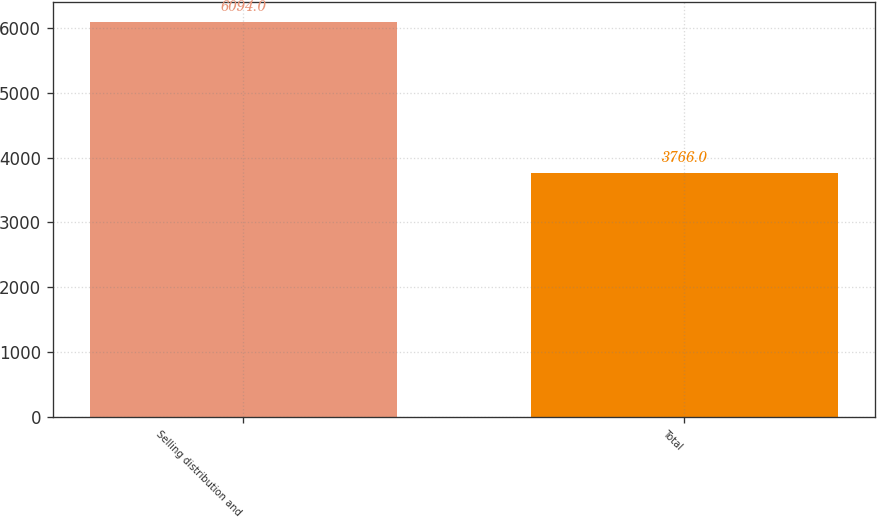<chart> <loc_0><loc_0><loc_500><loc_500><bar_chart><fcel>Selling distribution and<fcel>Total<nl><fcel>6094<fcel>3766<nl></chart> 